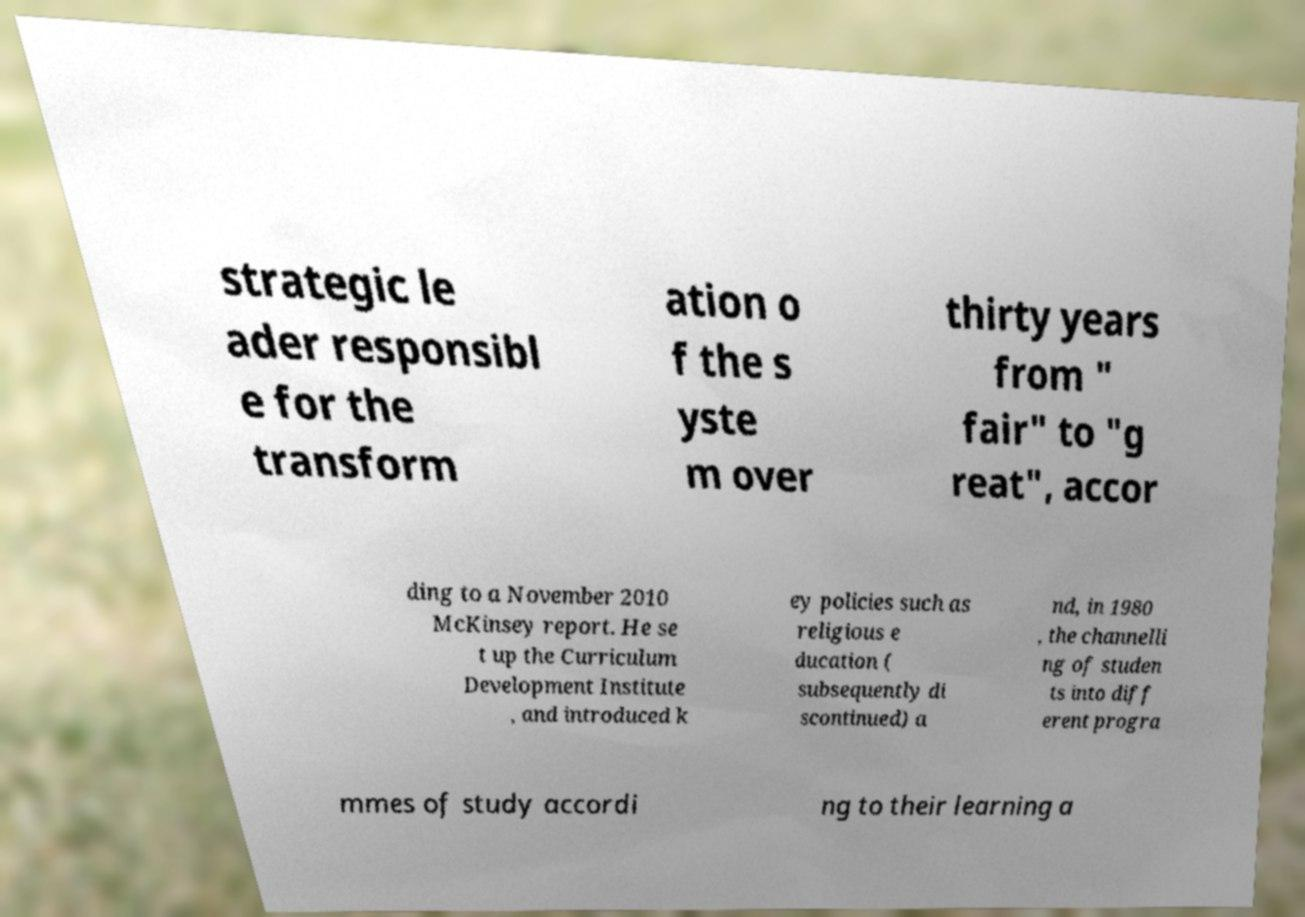Can you read and provide the text displayed in the image?This photo seems to have some interesting text. Can you extract and type it out for me? strategic le ader responsibl e for the transform ation o f the s yste m over thirty years from " fair" to "g reat", accor ding to a November 2010 McKinsey report. He se t up the Curriculum Development Institute , and introduced k ey policies such as religious e ducation ( subsequently di scontinued) a nd, in 1980 , the channelli ng of studen ts into diff erent progra mmes of study accordi ng to their learning a 